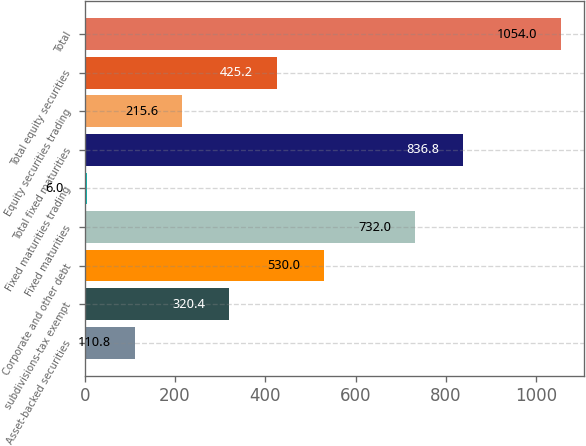Convert chart to OTSL. <chart><loc_0><loc_0><loc_500><loc_500><bar_chart><fcel>Asset-backed securities<fcel>subdivisions-tax exempt<fcel>Corporate and other debt<fcel>Fixed maturities<fcel>Fixed maturities trading<fcel>Total fixed maturities<fcel>Equity securities trading<fcel>Total equity securities<fcel>Total<nl><fcel>110.8<fcel>320.4<fcel>530<fcel>732<fcel>6<fcel>836.8<fcel>215.6<fcel>425.2<fcel>1054<nl></chart> 